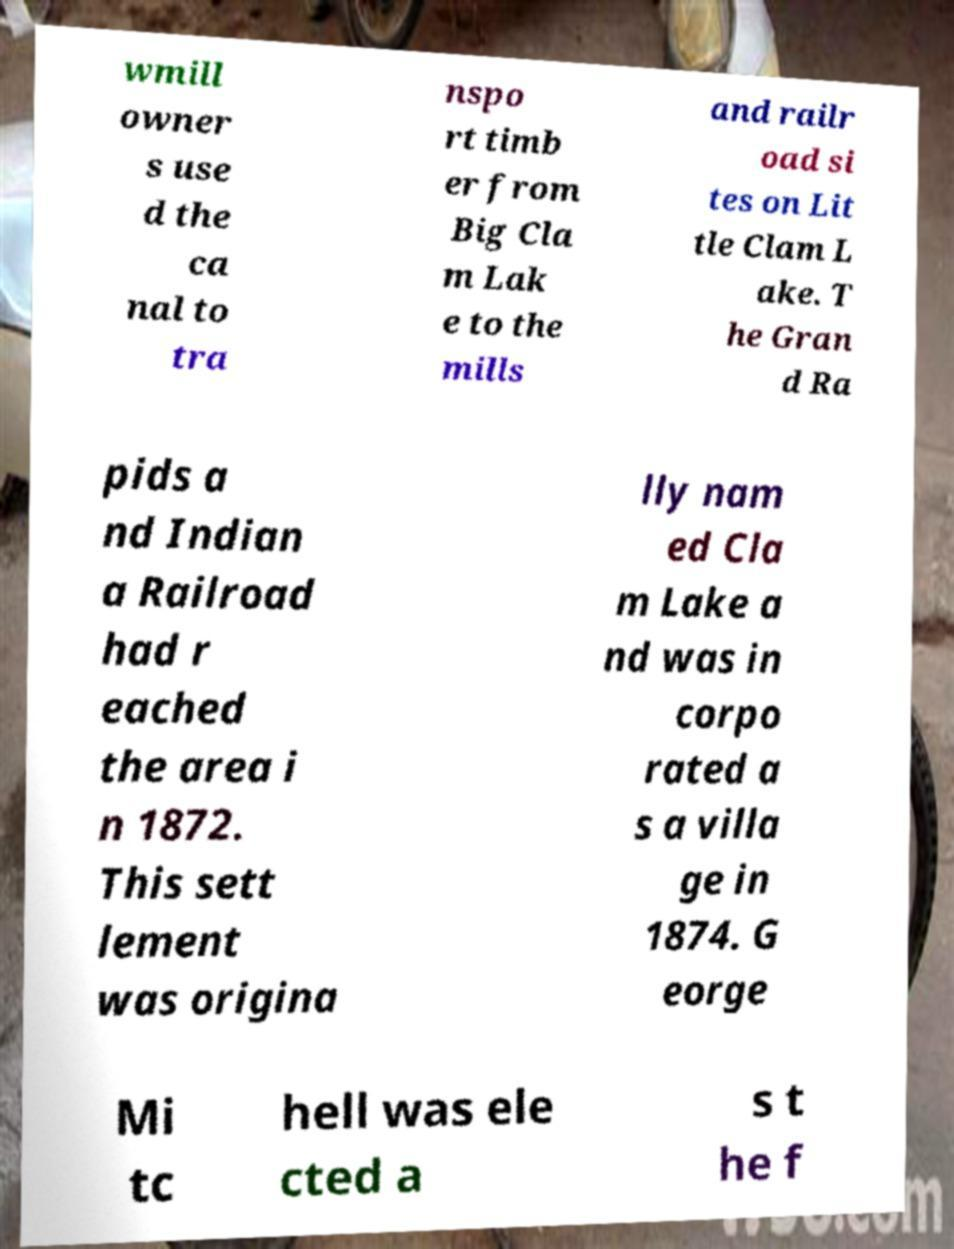For documentation purposes, I need the text within this image transcribed. Could you provide that? wmill owner s use d the ca nal to tra nspo rt timb er from Big Cla m Lak e to the mills and railr oad si tes on Lit tle Clam L ake. T he Gran d Ra pids a nd Indian a Railroad had r eached the area i n 1872. This sett lement was origina lly nam ed Cla m Lake a nd was in corpo rated a s a villa ge in 1874. G eorge Mi tc hell was ele cted a s t he f 